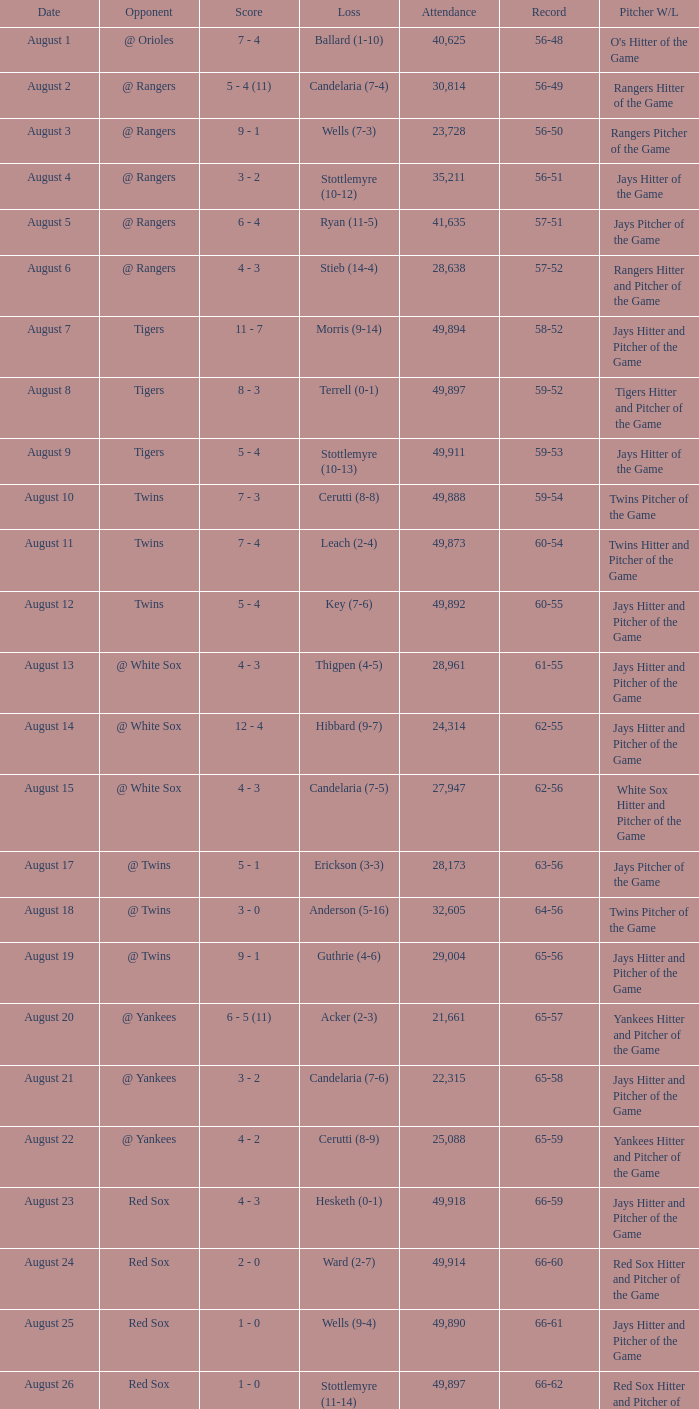What was the Attendance high on August 28? 49871.0. 